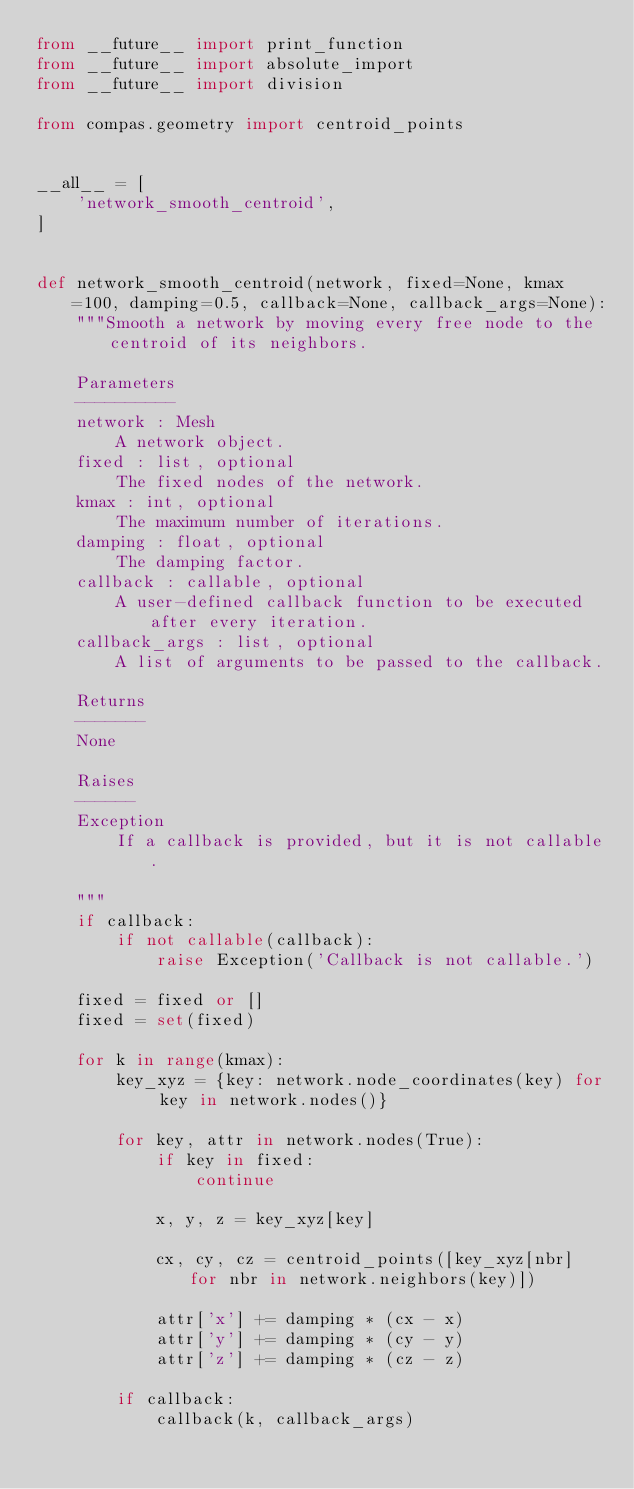<code> <loc_0><loc_0><loc_500><loc_500><_Python_>from __future__ import print_function
from __future__ import absolute_import
from __future__ import division

from compas.geometry import centroid_points


__all__ = [
    'network_smooth_centroid',
]


def network_smooth_centroid(network, fixed=None, kmax=100, damping=0.5, callback=None, callback_args=None):
    """Smooth a network by moving every free node to the centroid of its neighbors.

    Parameters
    ----------
    network : Mesh
        A network object.
    fixed : list, optional
        The fixed nodes of the network.
    kmax : int, optional
        The maximum number of iterations.
    damping : float, optional
        The damping factor.
    callback : callable, optional
        A user-defined callback function to be executed after every iteration.
    callback_args : list, optional
        A list of arguments to be passed to the callback.

    Returns
    -------
    None

    Raises
    ------
    Exception
        If a callback is provided, but it is not callable.

    """
    if callback:
        if not callable(callback):
            raise Exception('Callback is not callable.')

    fixed = fixed or []
    fixed = set(fixed)

    for k in range(kmax):
        key_xyz = {key: network.node_coordinates(key) for key in network.nodes()}

        for key, attr in network.nodes(True):
            if key in fixed:
                continue

            x, y, z = key_xyz[key]

            cx, cy, cz = centroid_points([key_xyz[nbr] for nbr in network.neighbors(key)])

            attr['x'] += damping * (cx - x)
            attr['y'] += damping * (cy - y)
            attr['z'] += damping * (cz - z)

        if callback:
            callback(k, callback_args)
</code> 